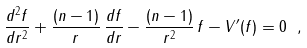Convert formula to latex. <formula><loc_0><loc_0><loc_500><loc_500>\frac { d ^ { 2 } f } { d r ^ { 2 } } + \frac { ( n - 1 ) } { r } \, \frac { d f } { d r } - \frac { ( n - 1 ) } { r ^ { 2 } } \, f - V ^ { \prime } ( f ) = 0 \ ,</formula> 